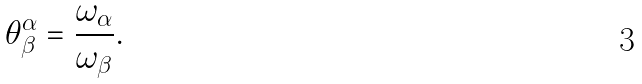<formula> <loc_0><loc_0><loc_500><loc_500>\theta _ { \beta } ^ { \alpha } = \frac { \omega _ { \alpha } } { \omega _ { \beta } } .</formula> 